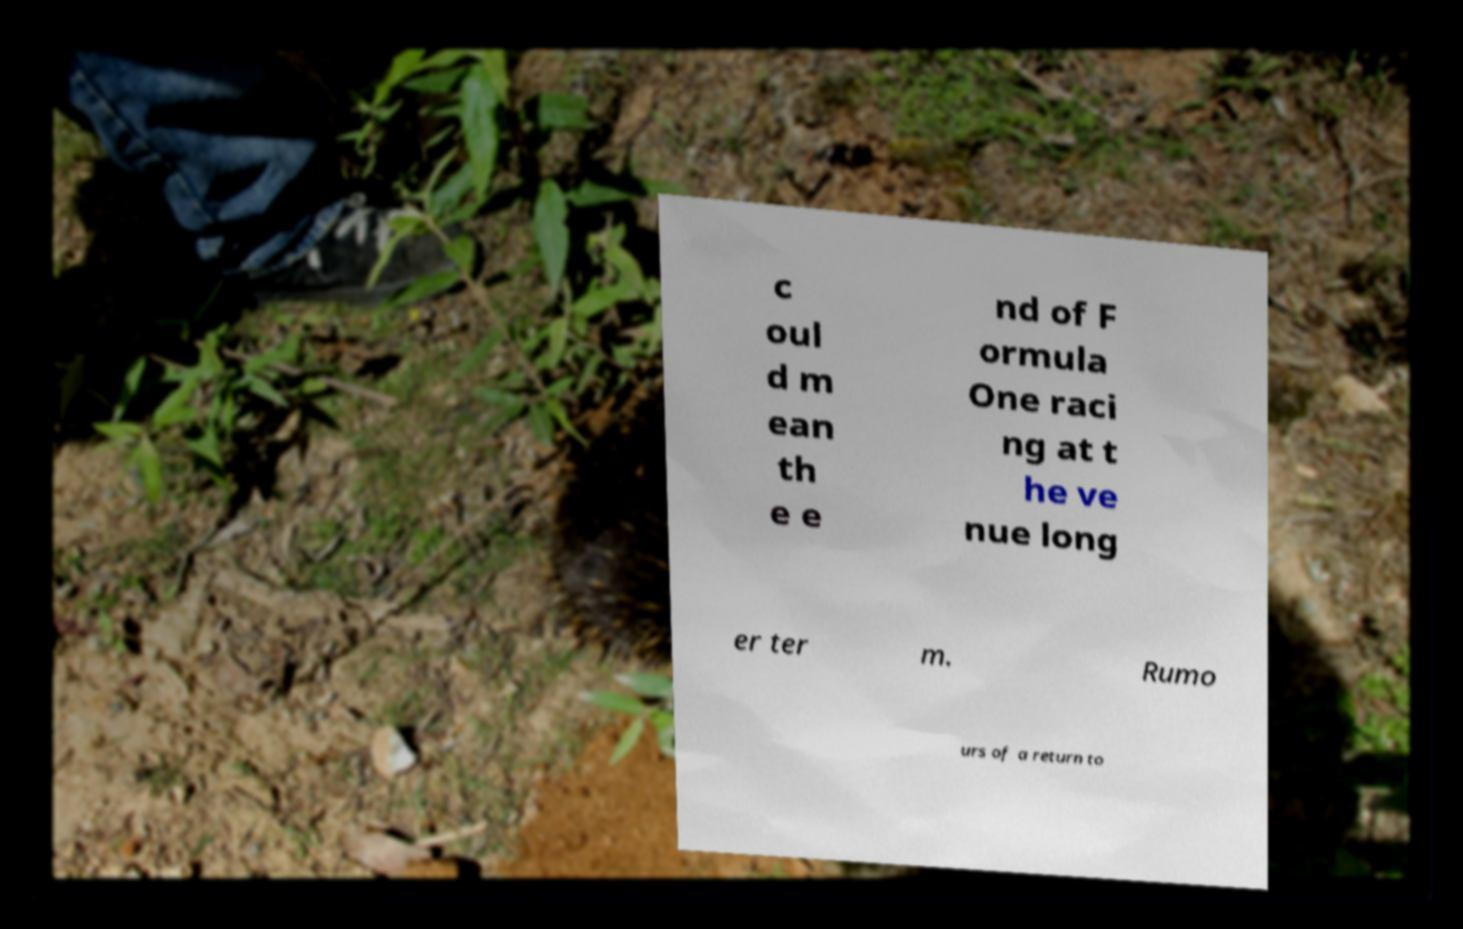I need the written content from this picture converted into text. Can you do that? c oul d m ean th e e nd of F ormula One raci ng at t he ve nue long er ter m. Rumo urs of a return to 